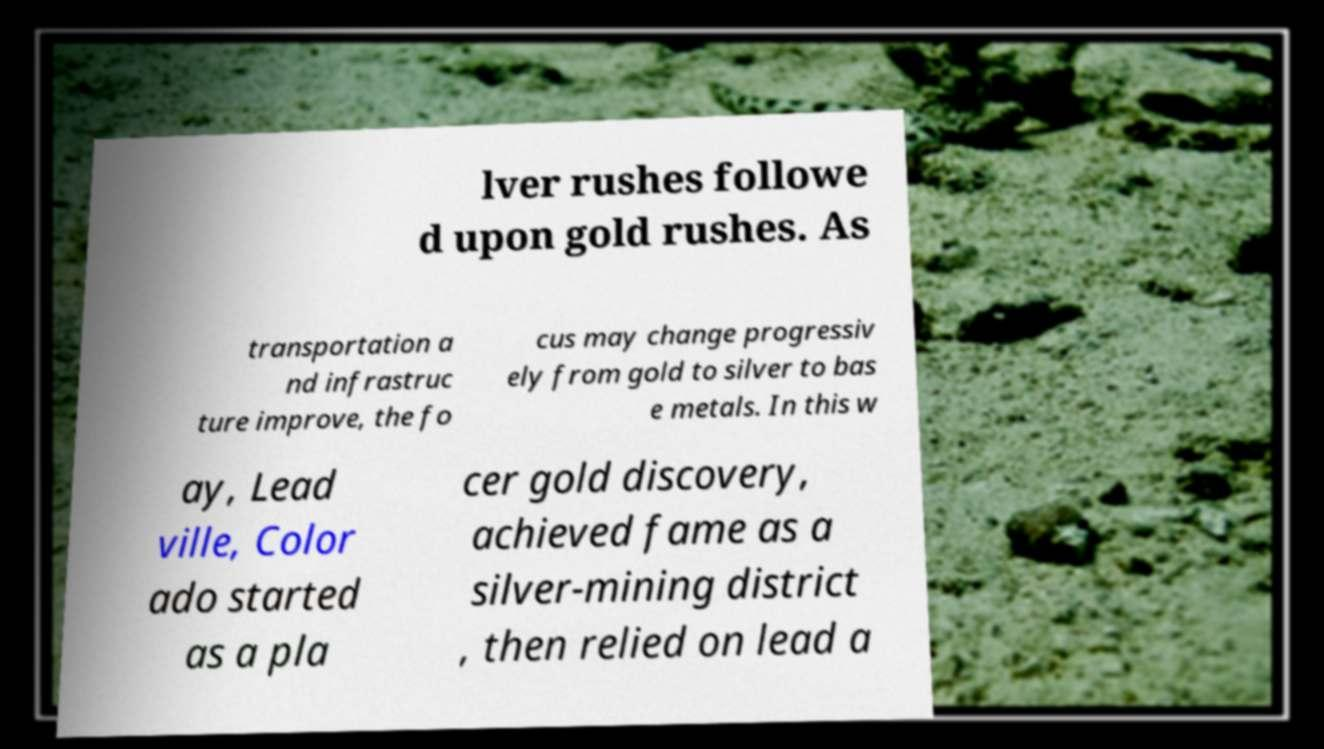I need the written content from this picture converted into text. Can you do that? lver rushes followe d upon gold rushes. As transportation a nd infrastruc ture improve, the fo cus may change progressiv ely from gold to silver to bas e metals. In this w ay, Lead ville, Color ado started as a pla cer gold discovery, achieved fame as a silver-mining district , then relied on lead a 